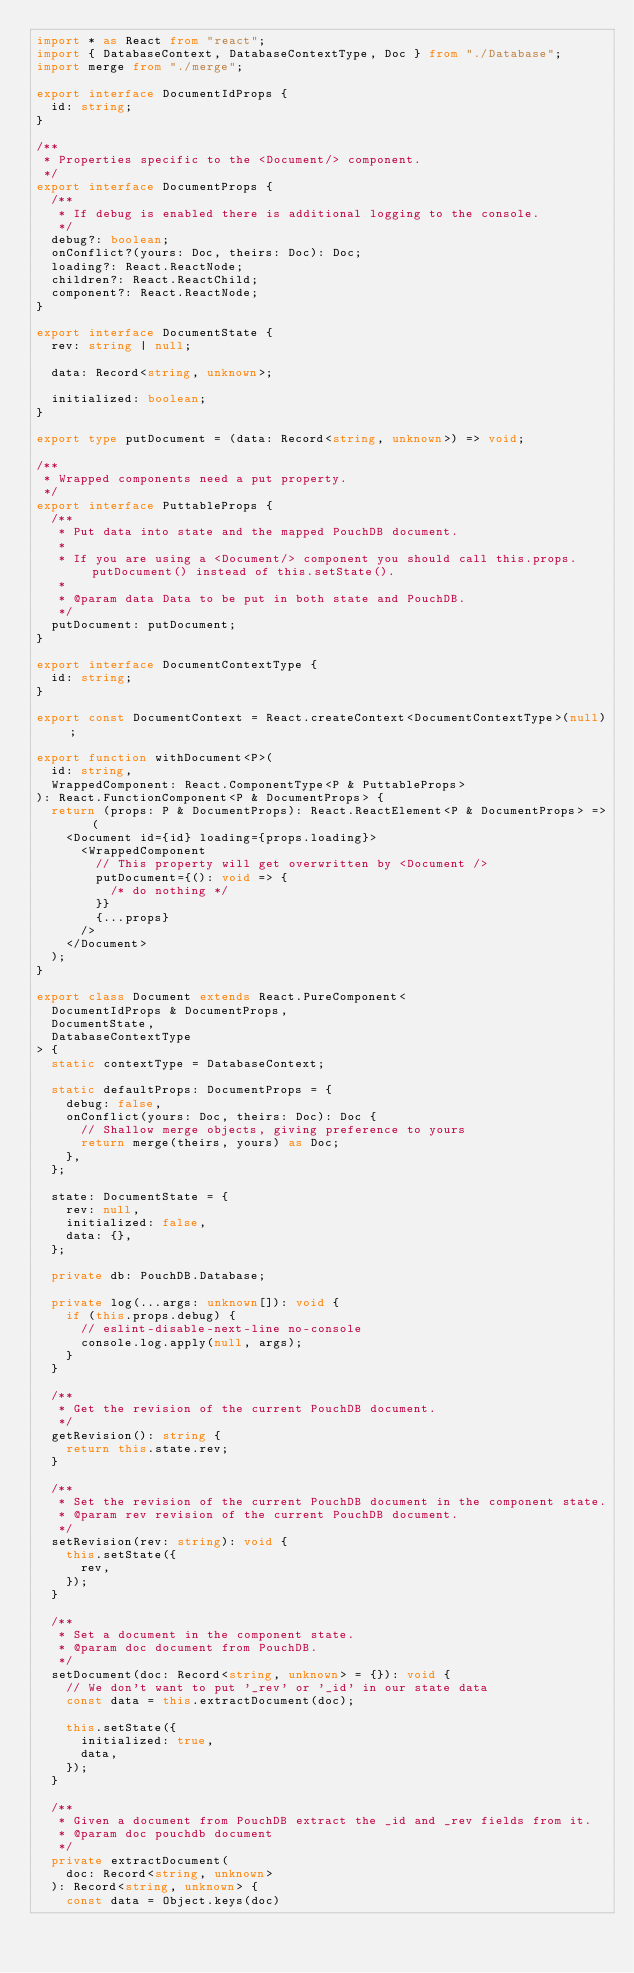Convert code to text. <code><loc_0><loc_0><loc_500><loc_500><_TypeScript_>import * as React from "react";
import { DatabaseContext, DatabaseContextType, Doc } from "./Database";
import merge from "./merge";

export interface DocumentIdProps {
  id: string;
}

/**
 * Properties specific to the <Document/> component.
 */
export interface DocumentProps {
  /**
   * If debug is enabled there is additional logging to the console.
   */
  debug?: boolean;
  onConflict?(yours: Doc, theirs: Doc): Doc;
  loading?: React.ReactNode;
  children?: React.ReactChild;
  component?: React.ReactNode;
}

export interface DocumentState {
  rev: string | null;

  data: Record<string, unknown>;

  initialized: boolean;
}

export type putDocument = (data: Record<string, unknown>) => void;

/**
 * Wrapped components need a put property.
 */
export interface PuttableProps {
  /**
   * Put data into state and the mapped PouchDB document.
   *
   * If you are using a <Document/> component you should call this.props.putDocument() instead of this.setState().
   *
   * @param data Data to be put in both state and PouchDB.
   */
  putDocument: putDocument;
}

export interface DocumentContextType {
  id: string;
}

export const DocumentContext = React.createContext<DocumentContextType>(null);

export function withDocument<P>(
  id: string,
  WrappedComponent: React.ComponentType<P & PuttableProps>
): React.FunctionComponent<P & DocumentProps> {
  return (props: P & DocumentProps): React.ReactElement<P & DocumentProps> => (
    <Document id={id} loading={props.loading}>
      <WrappedComponent
        // This property will get overwritten by <Document />
        putDocument={(): void => {
          /* do nothing */
        }}
        {...props}
      />
    </Document>
  );
}

export class Document extends React.PureComponent<
  DocumentIdProps & DocumentProps,
  DocumentState,
  DatabaseContextType
> {
  static contextType = DatabaseContext;

  static defaultProps: DocumentProps = {
    debug: false,
    onConflict(yours: Doc, theirs: Doc): Doc {
      // Shallow merge objects, giving preference to yours
      return merge(theirs, yours) as Doc;
    },
  };

  state: DocumentState = {
    rev: null,
    initialized: false,
    data: {},
  };

  private db: PouchDB.Database;

  private log(...args: unknown[]): void {
    if (this.props.debug) {
      // eslint-disable-next-line no-console
      console.log.apply(null, args);
    }
  }

  /**
   * Get the revision of the current PouchDB document.
   */
  getRevision(): string {
    return this.state.rev;
  }

  /**
   * Set the revision of the current PouchDB document in the component state.
   * @param rev revision of the current PouchDB document.
   */
  setRevision(rev: string): void {
    this.setState({
      rev,
    });
  }

  /**
   * Set a document in the component state.
   * @param doc document from PouchDB.
   */
  setDocument(doc: Record<string, unknown> = {}): void {
    // We don't want to put '_rev' or '_id' in our state data
    const data = this.extractDocument(doc);

    this.setState({
      initialized: true,
      data,
    });
  }

  /**
   * Given a document from PouchDB extract the _id and _rev fields from it.
   * @param doc pouchdb document
   */
  private extractDocument(
    doc: Record<string, unknown>
  ): Record<string, unknown> {
    const data = Object.keys(doc)</code> 